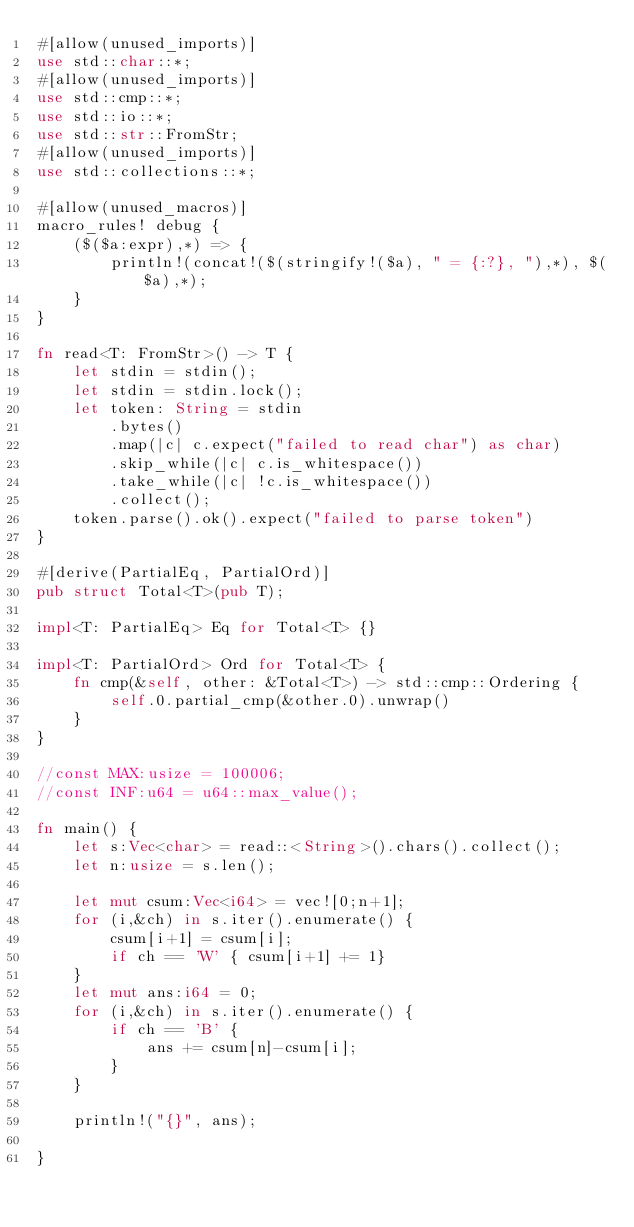Convert code to text. <code><loc_0><loc_0><loc_500><loc_500><_Rust_>#[allow(unused_imports)]
use std::char::*;
#[allow(unused_imports)]
use std::cmp::*;
use std::io::*;
use std::str::FromStr;
#[allow(unused_imports)]
use std::collections::*;

#[allow(unused_macros)]
macro_rules! debug {
    ($($a:expr),*) => {
        println!(concat!($(stringify!($a), " = {:?}, "),*), $($a),*);
    }
}

fn read<T: FromStr>() -> T {
    let stdin = stdin();
    let stdin = stdin.lock();
    let token: String = stdin
        .bytes()
        .map(|c| c.expect("failed to read char") as char)
        .skip_while(|c| c.is_whitespace())
        .take_while(|c| !c.is_whitespace())
        .collect();
    token.parse().ok().expect("failed to parse token")
}

#[derive(PartialEq, PartialOrd)]
pub struct Total<T>(pub T);

impl<T: PartialEq> Eq for Total<T> {}

impl<T: PartialOrd> Ord for Total<T> {
    fn cmp(&self, other: &Total<T>) -> std::cmp::Ordering {
        self.0.partial_cmp(&other.0).unwrap()
    }
}

//const MAX:usize = 100006;
//const INF:u64 = u64::max_value();

fn main() {
    let s:Vec<char> = read::<String>().chars().collect();
    let n:usize = s.len();

    let mut csum:Vec<i64> = vec![0;n+1];
    for (i,&ch) in s.iter().enumerate() {
        csum[i+1] = csum[i];
        if ch == 'W' { csum[i+1] += 1}
    }
    let mut ans:i64 = 0;
    for (i,&ch) in s.iter().enumerate() {
        if ch == 'B' {
            ans += csum[n]-csum[i];
        }
    }

    println!("{}", ans);

}
</code> 